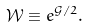Convert formula to latex. <formula><loc_0><loc_0><loc_500><loc_500>\mathcal { W } \equiv e ^ { \mathcal { G } / 2 } .</formula> 